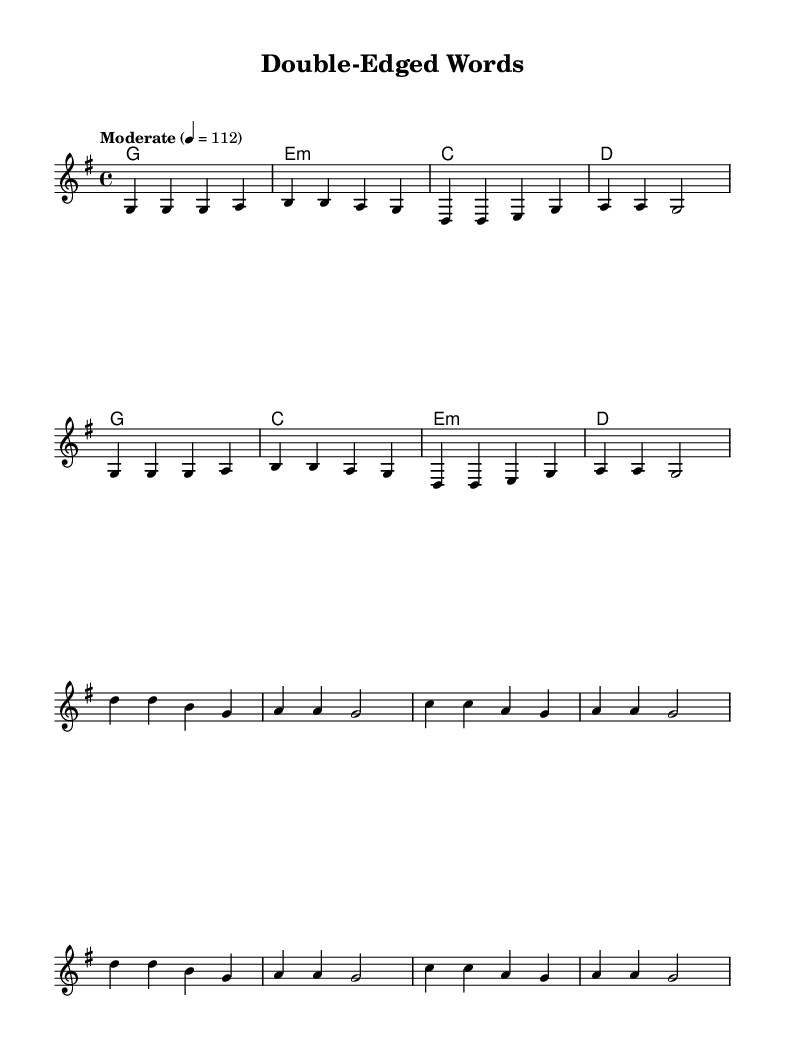What is the key signature of this music? The key signature shown in the music is G major, which has one sharp (F sharp). This can be identified at the beginning of the staff, where the sharp is indicated.
Answer: G major What is the time signature of the piece? The time signature is indicated at the beginning of the piece. It is displayed as 4 over 4, meaning there are four beats in each measure, and the quarter note gets the beat.
Answer: 4/4 What is the tempo marking for this piece? The tempo marking in the music is given as "Moderate" with a metronome setting of 4 equals 112. This indicates how fast the music should be played.
Answer: Moderate 4 = 112 How many measures are in the verse section? Counting the measures in the verse melody, there are a total of 8 measures. This is determined by observing the grouping of notes and bar lines that define each measure.
Answer: 8 What is the repeated phrase in the chorus lyrics? Upon examining the lyrics of the chorus, the phrase "a a g2" is notably repeated in the melody, indicating a common musical pattern that might signify importance.
Answer: a a g2 What do the lyrics suggest about the song's theme? The lyrics indicate a theme revolving around clever wordplay with meanings that can be interpreted in multiple ways. Phrases like "double-edged words" signal the exploration of significant yet ambiguous communication.
Answer: wordplay and double meanings How many chords are used in the harmonies section? The harmonies indicated in the music show four distinct chords used throughout: G, E minor, C, and D. This is evident from the chord symbols written above the staff.
Answer: 4 